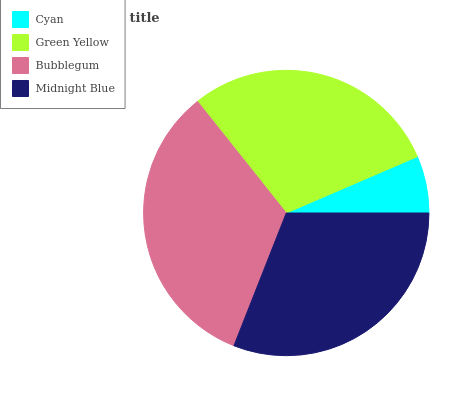Is Cyan the minimum?
Answer yes or no. Yes. Is Bubblegum the maximum?
Answer yes or no. Yes. Is Green Yellow the minimum?
Answer yes or no. No. Is Green Yellow the maximum?
Answer yes or no. No. Is Green Yellow greater than Cyan?
Answer yes or no. Yes. Is Cyan less than Green Yellow?
Answer yes or no. Yes. Is Cyan greater than Green Yellow?
Answer yes or no. No. Is Green Yellow less than Cyan?
Answer yes or no. No. Is Midnight Blue the high median?
Answer yes or no. Yes. Is Green Yellow the low median?
Answer yes or no. Yes. Is Bubblegum the high median?
Answer yes or no. No. Is Cyan the low median?
Answer yes or no. No. 